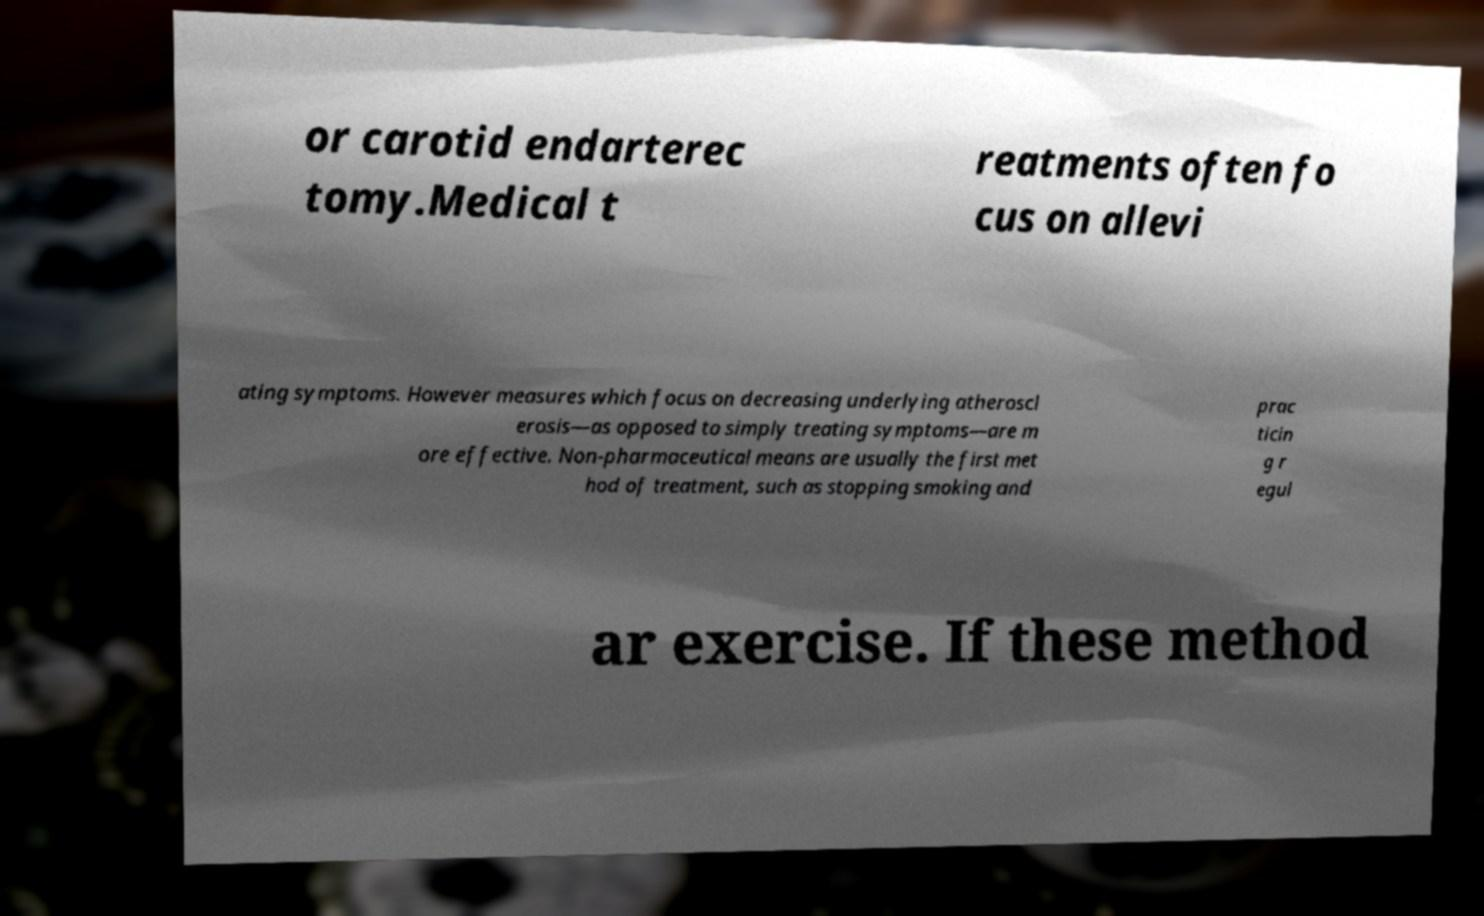Could you assist in decoding the text presented in this image and type it out clearly? or carotid endarterec tomy.Medical t reatments often fo cus on allevi ating symptoms. However measures which focus on decreasing underlying atheroscl erosis—as opposed to simply treating symptoms—are m ore effective. Non-pharmaceutical means are usually the first met hod of treatment, such as stopping smoking and prac ticin g r egul ar exercise. If these method 